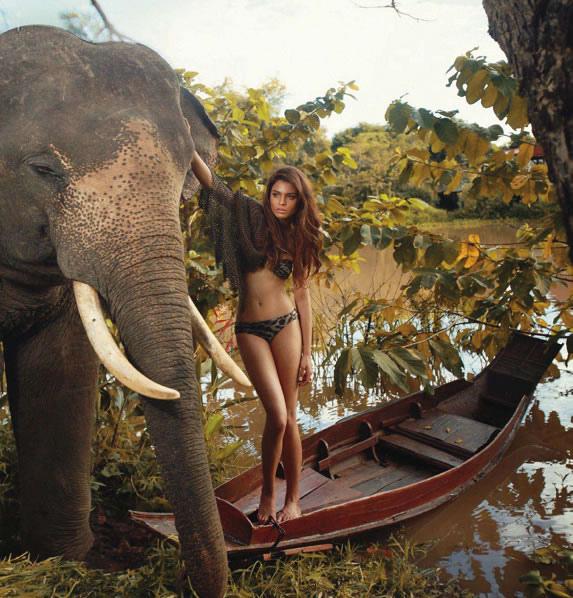Does the girl's head look off-center from the rest of her body?
Short answer required. Yes. Was this image digitally altered?
Short answer required. Yes. How many elephants are in this scene?
Quick response, please. 1. 